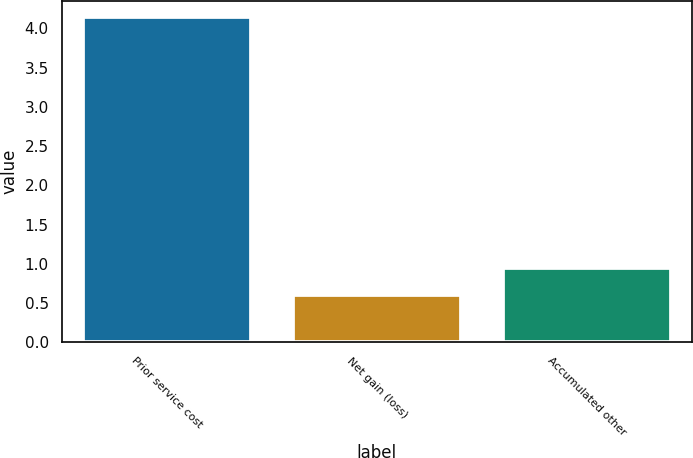<chart> <loc_0><loc_0><loc_500><loc_500><bar_chart><fcel>Prior service cost<fcel>Net gain (loss)<fcel>Accumulated other<nl><fcel>4.14<fcel>0.6<fcel>0.95<nl></chart> 